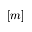Convert formula to latex. <formula><loc_0><loc_0><loc_500><loc_500>[ m ]</formula> 